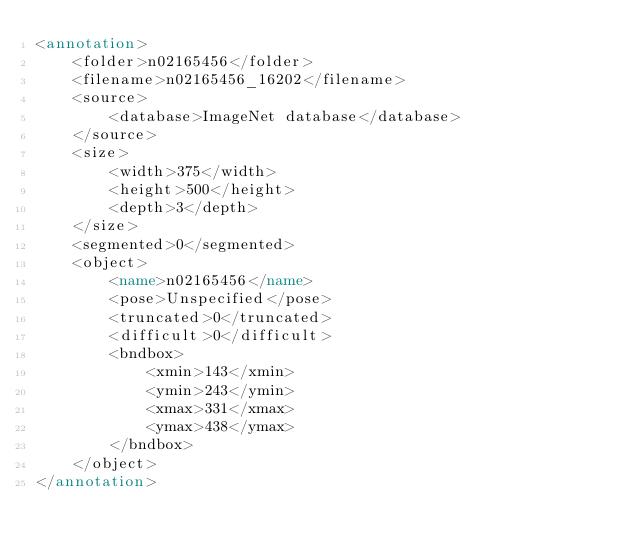Convert code to text. <code><loc_0><loc_0><loc_500><loc_500><_XML_><annotation>
	<folder>n02165456</folder>
	<filename>n02165456_16202</filename>
	<source>
		<database>ImageNet database</database>
	</source>
	<size>
		<width>375</width>
		<height>500</height>
		<depth>3</depth>
	</size>
	<segmented>0</segmented>
	<object>
		<name>n02165456</name>
		<pose>Unspecified</pose>
		<truncated>0</truncated>
		<difficult>0</difficult>
		<bndbox>
			<xmin>143</xmin>
			<ymin>243</ymin>
			<xmax>331</xmax>
			<ymax>438</ymax>
		</bndbox>
	</object>
</annotation></code> 